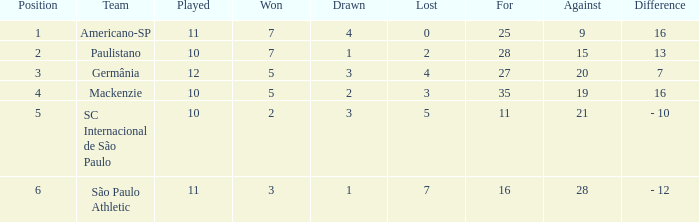Name the least for when played is 12 27.0. 